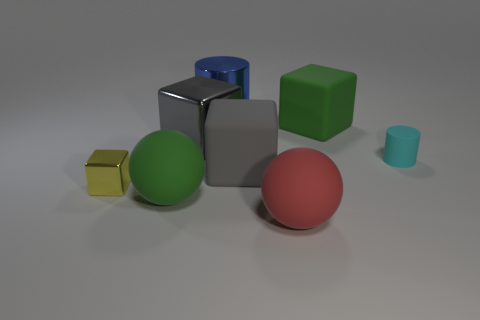Subtract all large shiny blocks. How many blocks are left? 3 Subtract 3 cubes. How many cubes are left? 1 Subtract all blue balls. Subtract all gray cylinders. How many balls are left? 2 Subtract all red cylinders. How many green cubes are left? 1 Subtract all large green metallic balls. Subtract all gray rubber objects. How many objects are left? 7 Add 7 big red rubber objects. How many big red rubber objects are left? 8 Add 2 tiny brown shiny cylinders. How many tiny brown shiny cylinders exist? 2 Add 1 matte cylinders. How many objects exist? 9 Subtract all blue cylinders. How many cylinders are left? 1 Subtract 1 yellow cubes. How many objects are left? 7 